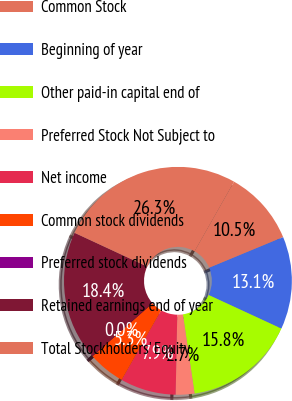Convert chart to OTSL. <chart><loc_0><loc_0><loc_500><loc_500><pie_chart><fcel>Common Stock<fcel>Beginning of year<fcel>Other paid-in capital end of<fcel>Preferred Stock Not Subject to<fcel>Net income<fcel>Common stock dividends<fcel>Preferred stock dividends<fcel>Retained earnings end of year<fcel>Total Stockholders' Equity<nl><fcel>10.53%<fcel>13.15%<fcel>15.78%<fcel>2.65%<fcel>7.9%<fcel>5.27%<fcel>0.02%<fcel>18.41%<fcel>26.29%<nl></chart> 